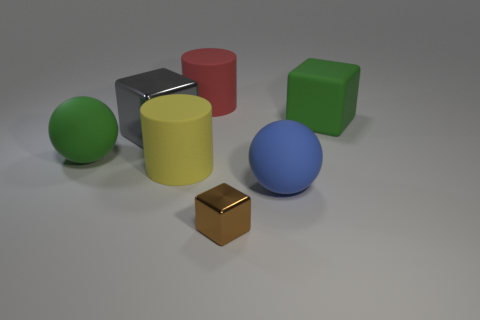Subtract all big matte blocks. How many blocks are left? 2 Add 2 large rubber blocks. How many objects exist? 9 Subtract all cubes. How many objects are left? 4 Subtract 1 gray blocks. How many objects are left? 6 Subtract all large things. Subtract all big brown matte cylinders. How many objects are left? 1 Add 7 blue balls. How many blue balls are left? 8 Add 2 yellow objects. How many yellow objects exist? 3 